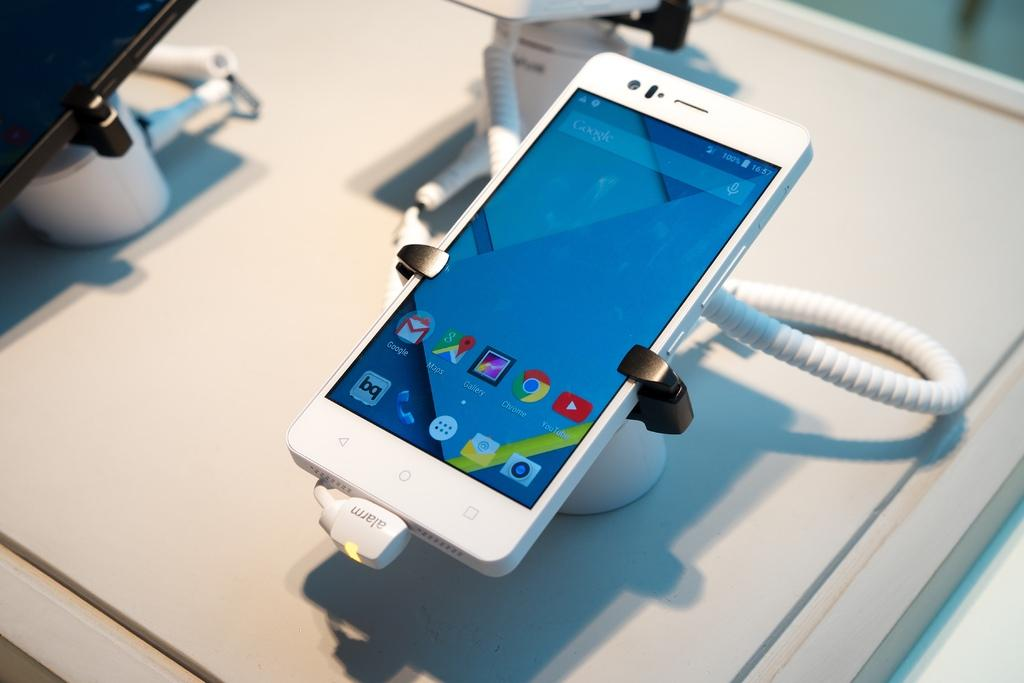What type of furniture is in the image? There is a table in the image. What is placed on the table? Electronic gadgets and charging cables are visible on the table. Are there any other objects on the table besides electronic gadgets and charging cables? Yes, there are other objects on the table. How do the sisters feel about the increase in pleasure they experience from using the electronic gadgets? There is no mention of sisters or pleasure in the image, so we cannot answer this question based on the provided facts. 